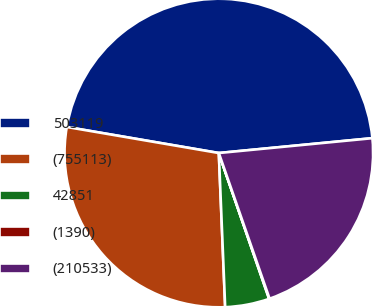<chart> <loc_0><loc_0><loc_500><loc_500><pie_chart><fcel>503119<fcel>(755113)<fcel>42851<fcel>(1390)<fcel>(210533)<nl><fcel>45.77%<fcel>28.36%<fcel>4.63%<fcel>0.05%<fcel>21.2%<nl></chart> 